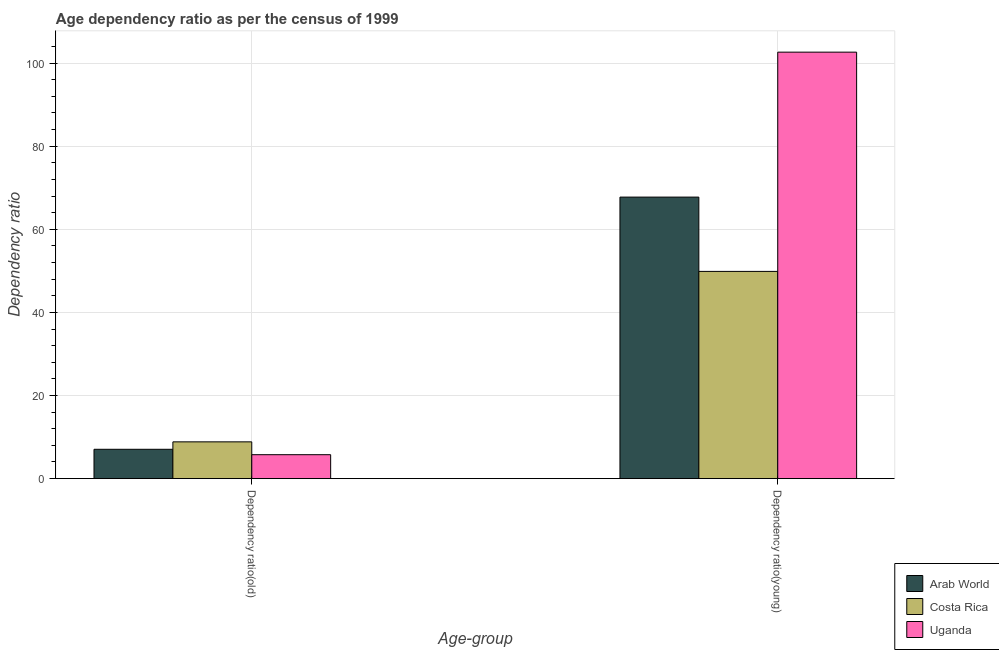Are the number of bars per tick equal to the number of legend labels?
Make the answer very short. Yes. Are the number of bars on each tick of the X-axis equal?
Your response must be concise. Yes. How many bars are there on the 2nd tick from the left?
Offer a very short reply. 3. How many bars are there on the 2nd tick from the right?
Offer a very short reply. 3. What is the label of the 2nd group of bars from the left?
Make the answer very short. Dependency ratio(young). What is the age dependency ratio(young) in Costa Rica?
Provide a succinct answer. 49.87. Across all countries, what is the maximum age dependency ratio(old)?
Offer a terse response. 8.85. Across all countries, what is the minimum age dependency ratio(old)?
Provide a succinct answer. 5.76. In which country was the age dependency ratio(young) minimum?
Provide a short and direct response. Costa Rica. What is the total age dependency ratio(old) in the graph?
Provide a succinct answer. 21.66. What is the difference between the age dependency ratio(young) in Costa Rica and that in Arab World?
Offer a very short reply. -17.88. What is the difference between the age dependency ratio(old) in Arab World and the age dependency ratio(young) in Uganda?
Keep it short and to the point. -95.58. What is the average age dependency ratio(old) per country?
Provide a succinct answer. 7.22. What is the difference between the age dependency ratio(old) and age dependency ratio(young) in Costa Rica?
Give a very brief answer. -41.02. What is the ratio of the age dependency ratio(old) in Costa Rica to that in Arab World?
Provide a short and direct response. 1.25. Is the age dependency ratio(young) in Arab World less than that in Uganda?
Your answer should be very brief. Yes. In how many countries, is the age dependency ratio(old) greater than the average age dependency ratio(old) taken over all countries?
Keep it short and to the point. 1. What does the 3rd bar from the left in Dependency ratio(young) represents?
Your answer should be compact. Uganda. What does the 3rd bar from the right in Dependency ratio(old) represents?
Give a very brief answer. Arab World. How many bars are there?
Offer a terse response. 6. Does the graph contain any zero values?
Your response must be concise. No. Does the graph contain grids?
Make the answer very short. Yes. How many legend labels are there?
Keep it short and to the point. 3. How are the legend labels stacked?
Offer a very short reply. Vertical. What is the title of the graph?
Your answer should be compact. Age dependency ratio as per the census of 1999. What is the label or title of the X-axis?
Give a very brief answer. Age-group. What is the label or title of the Y-axis?
Your response must be concise. Dependency ratio. What is the Dependency ratio of Arab World in Dependency ratio(old)?
Provide a short and direct response. 7.06. What is the Dependency ratio of Costa Rica in Dependency ratio(old)?
Ensure brevity in your answer.  8.85. What is the Dependency ratio of Uganda in Dependency ratio(old)?
Offer a terse response. 5.76. What is the Dependency ratio of Arab World in Dependency ratio(young)?
Ensure brevity in your answer.  67.75. What is the Dependency ratio in Costa Rica in Dependency ratio(young)?
Offer a terse response. 49.87. What is the Dependency ratio in Uganda in Dependency ratio(young)?
Offer a very short reply. 102.63. Across all Age-group, what is the maximum Dependency ratio of Arab World?
Your answer should be compact. 67.75. Across all Age-group, what is the maximum Dependency ratio in Costa Rica?
Your answer should be very brief. 49.87. Across all Age-group, what is the maximum Dependency ratio in Uganda?
Ensure brevity in your answer.  102.63. Across all Age-group, what is the minimum Dependency ratio of Arab World?
Provide a succinct answer. 7.06. Across all Age-group, what is the minimum Dependency ratio in Costa Rica?
Your answer should be very brief. 8.85. Across all Age-group, what is the minimum Dependency ratio of Uganda?
Your answer should be very brief. 5.76. What is the total Dependency ratio in Arab World in the graph?
Make the answer very short. 74.81. What is the total Dependency ratio of Costa Rica in the graph?
Your response must be concise. 58.71. What is the total Dependency ratio in Uganda in the graph?
Provide a succinct answer. 108.39. What is the difference between the Dependency ratio in Arab World in Dependency ratio(old) and that in Dependency ratio(young)?
Your response must be concise. -60.69. What is the difference between the Dependency ratio in Costa Rica in Dependency ratio(old) and that in Dependency ratio(young)?
Ensure brevity in your answer.  -41.02. What is the difference between the Dependency ratio of Uganda in Dependency ratio(old) and that in Dependency ratio(young)?
Provide a short and direct response. -96.88. What is the difference between the Dependency ratio of Arab World in Dependency ratio(old) and the Dependency ratio of Costa Rica in Dependency ratio(young)?
Keep it short and to the point. -42.81. What is the difference between the Dependency ratio of Arab World in Dependency ratio(old) and the Dependency ratio of Uganda in Dependency ratio(young)?
Keep it short and to the point. -95.58. What is the difference between the Dependency ratio of Costa Rica in Dependency ratio(old) and the Dependency ratio of Uganda in Dependency ratio(young)?
Provide a succinct answer. -93.79. What is the average Dependency ratio in Arab World per Age-group?
Make the answer very short. 37.4. What is the average Dependency ratio in Costa Rica per Age-group?
Keep it short and to the point. 29.36. What is the average Dependency ratio in Uganda per Age-group?
Your response must be concise. 54.2. What is the difference between the Dependency ratio in Arab World and Dependency ratio in Costa Rica in Dependency ratio(old)?
Your response must be concise. -1.79. What is the difference between the Dependency ratio of Arab World and Dependency ratio of Uganda in Dependency ratio(old)?
Make the answer very short. 1.3. What is the difference between the Dependency ratio of Costa Rica and Dependency ratio of Uganda in Dependency ratio(old)?
Offer a terse response. 3.09. What is the difference between the Dependency ratio in Arab World and Dependency ratio in Costa Rica in Dependency ratio(young)?
Offer a very short reply. 17.88. What is the difference between the Dependency ratio of Arab World and Dependency ratio of Uganda in Dependency ratio(young)?
Give a very brief answer. -34.88. What is the difference between the Dependency ratio in Costa Rica and Dependency ratio in Uganda in Dependency ratio(young)?
Make the answer very short. -52.77. What is the ratio of the Dependency ratio in Arab World in Dependency ratio(old) to that in Dependency ratio(young)?
Give a very brief answer. 0.1. What is the ratio of the Dependency ratio in Costa Rica in Dependency ratio(old) to that in Dependency ratio(young)?
Offer a very short reply. 0.18. What is the ratio of the Dependency ratio in Uganda in Dependency ratio(old) to that in Dependency ratio(young)?
Your response must be concise. 0.06. What is the difference between the highest and the second highest Dependency ratio in Arab World?
Provide a short and direct response. 60.69. What is the difference between the highest and the second highest Dependency ratio of Costa Rica?
Provide a succinct answer. 41.02. What is the difference between the highest and the second highest Dependency ratio of Uganda?
Offer a very short reply. 96.88. What is the difference between the highest and the lowest Dependency ratio in Arab World?
Provide a short and direct response. 60.69. What is the difference between the highest and the lowest Dependency ratio of Costa Rica?
Provide a short and direct response. 41.02. What is the difference between the highest and the lowest Dependency ratio of Uganda?
Make the answer very short. 96.88. 